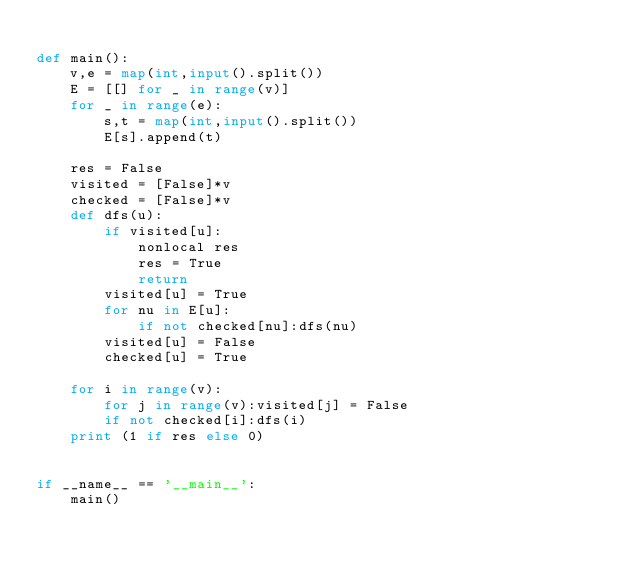Convert code to text. <code><loc_0><loc_0><loc_500><loc_500><_Python_>
def main():
    v,e = map(int,input().split())
    E = [[] for _ in range(v)]
    for _ in range(e):
        s,t = map(int,input().split())
        E[s].append(t)

    res = False
    visited = [False]*v
    checked = [False]*v
    def dfs(u):
        if visited[u]:
            nonlocal res
            res = True
            return
        visited[u] = True
        for nu in E[u]:
            if not checked[nu]:dfs(nu)
        visited[u] = False
        checked[u] = True

    for i in range(v):
        for j in range(v):visited[j] = False
        if not checked[i]:dfs(i)
    print (1 if res else 0)


if __name__ == '__main__':
    main()


</code> 